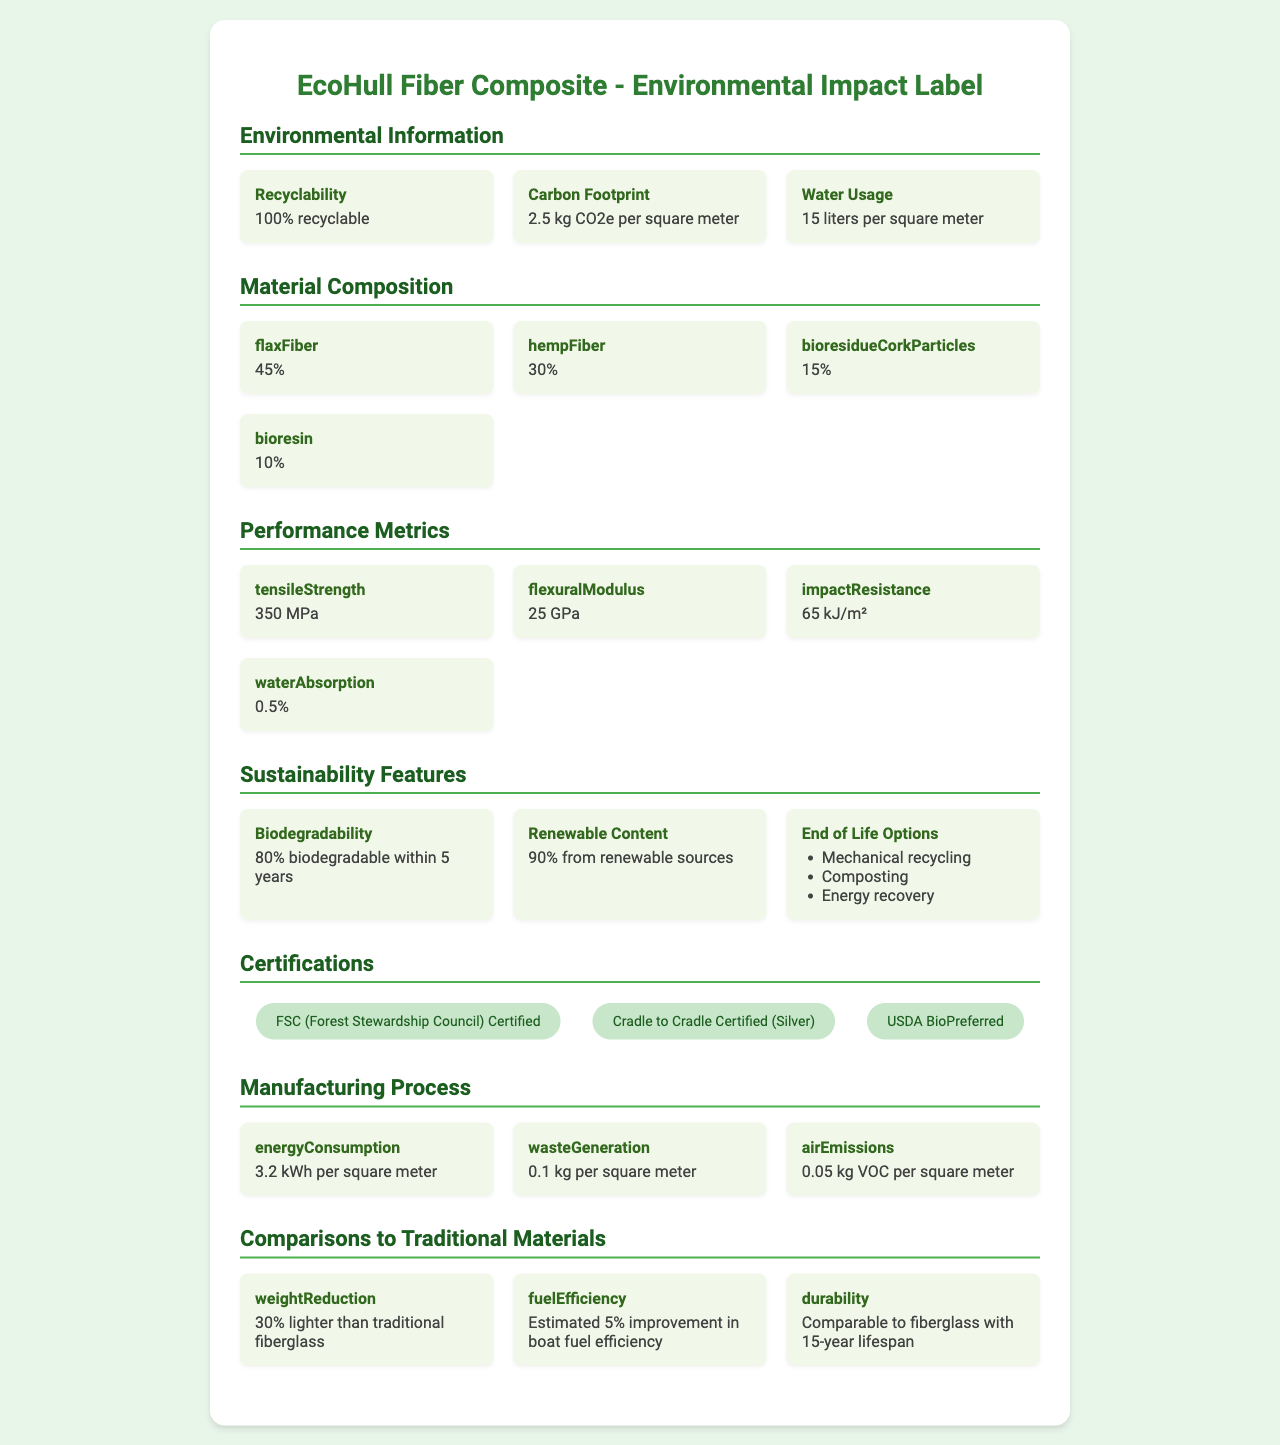what is the recyclability of EcoHull Fiber Composite? The document states in the Environmental Information section that the EcoHull Fiber Composite is 100% recyclable.
Answer: 100% recyclable how much carbon footprint does EcoHull Fiber Composite generate per square meter? According to the Environmental Information section, the carbon footprint is 2.5 kg CO2e per square meter.
Answer: 2.5 kg CO2e per square meter what is the water usage of EcoHull Fiber Composite per square meter? In the Environmental Information section, it is mentioned that the water usage is 15 liters per square meter.
Answer: 15 liters per square meter what percentage of the EcoHull Fiber Composite is made from hemp fiber? The Material Composition section shows that 30% of the composite is made from hemp fiber.
Answer: 30% how long does EcoHull Fiber Composite take to biodegrade by 80%? The Sustainability Features section notes that the material is 80% biodegradable within 5 years.
Answer: 5 years which of the following is not one of the end-of-life options for EcoHull Fiber Composite? A. Mechanical recycling B. Composting C. Incineration D. Energy recovery The End of Life Options listed in the Sustainability Features section include Mechanical recycling, Composting, and Energy recovery, but not Incineration.
Answer: C. Incineration which certification indicates that EcoHull Fiber Composite uses responsibly sourced wood? A. USDA BioPreferred B. Cradle to Cradle Certified (Silver) C. FSC Certified The FSC (Forest Stewardship Council) certification is specifically for responsibly sourced wood.
Answer: C. FSC Certified is EcoHull Fiber Composite considered a renewable material? The Sustainability Features section states that 90% of the material is from renewable sources.
Answer: Yes does EcoHull Fiber Composite contain any dietary fiber? The Nutrition Facts section specifies that it contains 0g of dietary fiber.
Answer: No what are the main sustainability features of EcoHull Fiber Composite? The Sustainability Features section outlines that the material is 80% biodegradable within 5 years, has 90% renewable content, and offers options for Mechanical recycling, Composting, and Energy recovery.
Answer: Biodegradability, Renewable Content, End of Life Options what is the tensile strength of EcoHull Fiber Composite? The Performance Metrics section mentions that the tensile strength is 350 MPa.
Answer: 350 MPa how much energy consumption is involved in manufacturing EcoHull Fiber Composite per square meter? The Manufacturing Process section indicates that the energy consumption is 3.2 kWh per square meter.
Answer: 3.2 kWh per square meter is the EcoHull Fiber Composite heavier than traditional fiberglass? According to the Comparisons section, EcoHull Fiber Composite is 30% lighter than traditional fiberglass.
Answer: No what are the certifications achieved by EcoHull Fiber Composite? The Certifications section lists these three certifications.
Answer: FSC Certified, Cradle to Cradle Certified (Silver), USDA BioPreferred can the specific strength of EcoHull Fiber Composite be found in the document? The document does not mention the specific strength, only the tensile strength, flexural modulus, and impact resistance.
Answer: Not enough information 